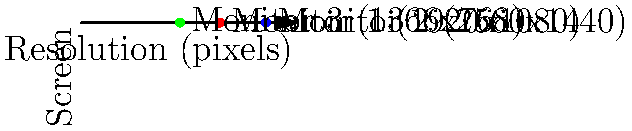In your Linux setup, you have three monitors with different resolutions as shown in the graph. Which command-line tool would you use to configure these monitors and adjust their relative positions? To configure multiple monitors with different resolutions in Linux, follow these steps:

1. Identify the tool: The most common command-line tool for configuring displays in Linux is `xrandr`.

2. List available outputs: Run `xrandr` without arguments to see connected monitors and their supported resolutions.

3. Configure each monitor: Use `xrandr` with the `--output` option followed by the monitor name and its settings. For example:
   ```
   xrandr --output HDMI-1 --mode 1920x1080 --pos 0x0
   xrandr --output DP-1 --mode 2560x1440 --pos 1920x0
   xrandr --output VGA-1 --mode 1366x768 --pos 4480x0
   ```

4. Adjust positions: The `--pos` option sets the top-left corner coordinates of each monitor relative to the virtual screen.

5. Save configuration: To make the setup persistent, add these commands to your `.xinitrc` or `.xprofile` file.

The `xrandr` tool provides a flexible way to manage multiple monitors with varying resolutions in Linux, making it ideal for retirees new to the operating system who need to configure their display setup.
Answer: xrandr 